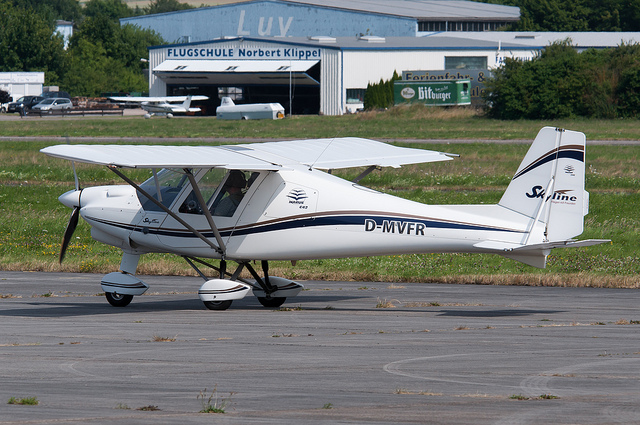Please extract the text content from this image. L u v Skyline D-MVFR bitburger &amp; Klippel Norbert FLUGSCHULE 